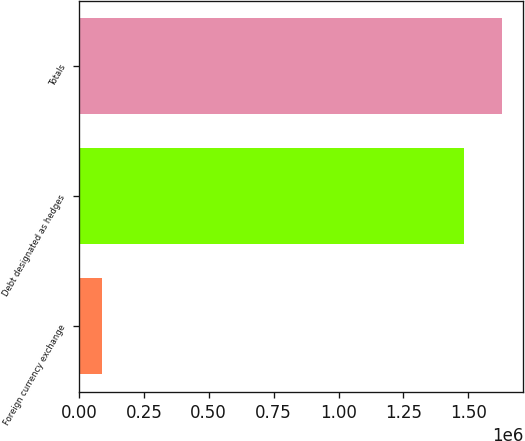<chart> <loc_0><loc_0><loc_500><loc_500><bar_chart><fcel>Foreign currency exchange<fcel>Debt designated as hedges<fcel>Totals<nl><fcel>87962<fcel>1.48159e+06<fcel>1.62975e+06<nl></chart> 